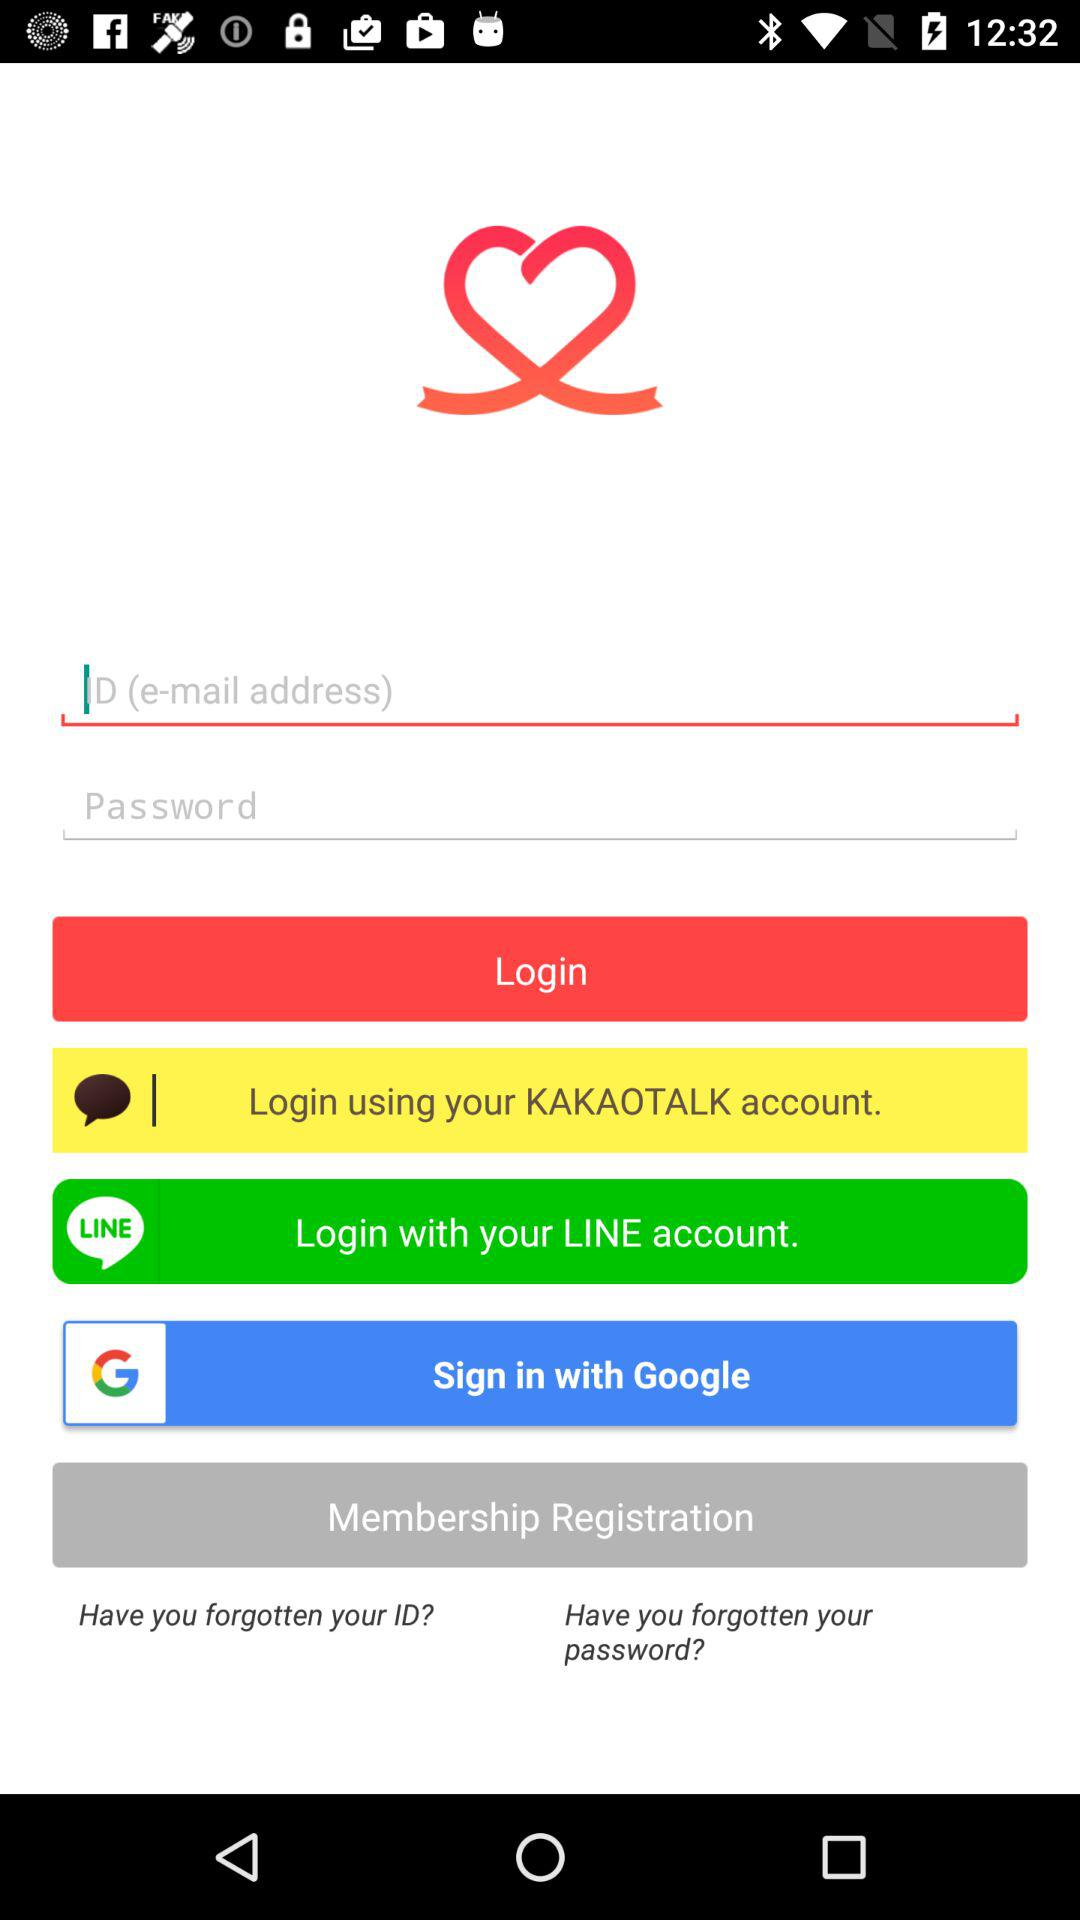How can we sign in? We can sign in with "KAKAOTALK", "LINE" and "Google". 